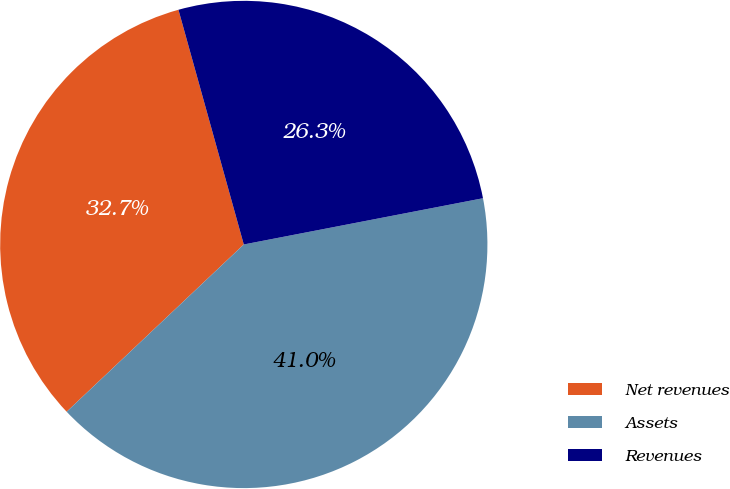Convert chart. <chart><loc_0><loc_0><loc_500><loc_500><pie_chart><fcel>Net revenues<fcel>Assets<fcel>Revenues<nl><fcel>32.72%<fcel>40.99%<fcel>26.28%<nl></chart> 